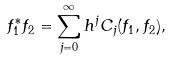Convert formula to latex. <formula><loc_0><loc_0><loc_500><loc_500>f _ { 1 } ^ { * } f _ { 2 } = \sum _ { j = 0 } ^ { \infty } h ^ { j } C _ { j } ( f _ { 1 } , f _ { 2 } ) ,</formula> 